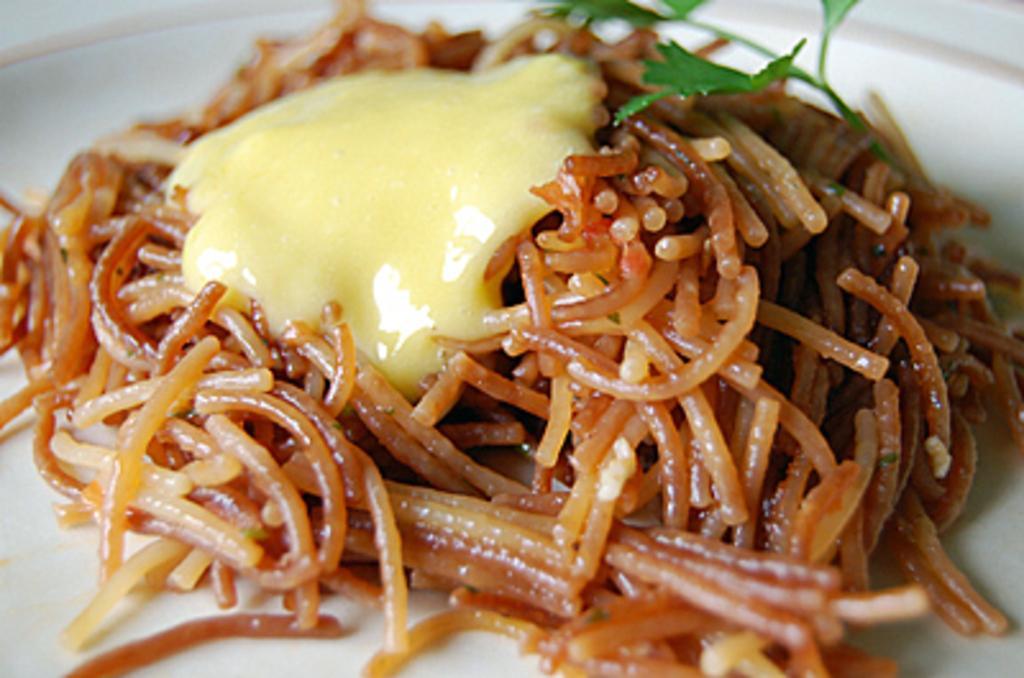Describe this image in one or two sentences. In this image we can see the plate of food item. 